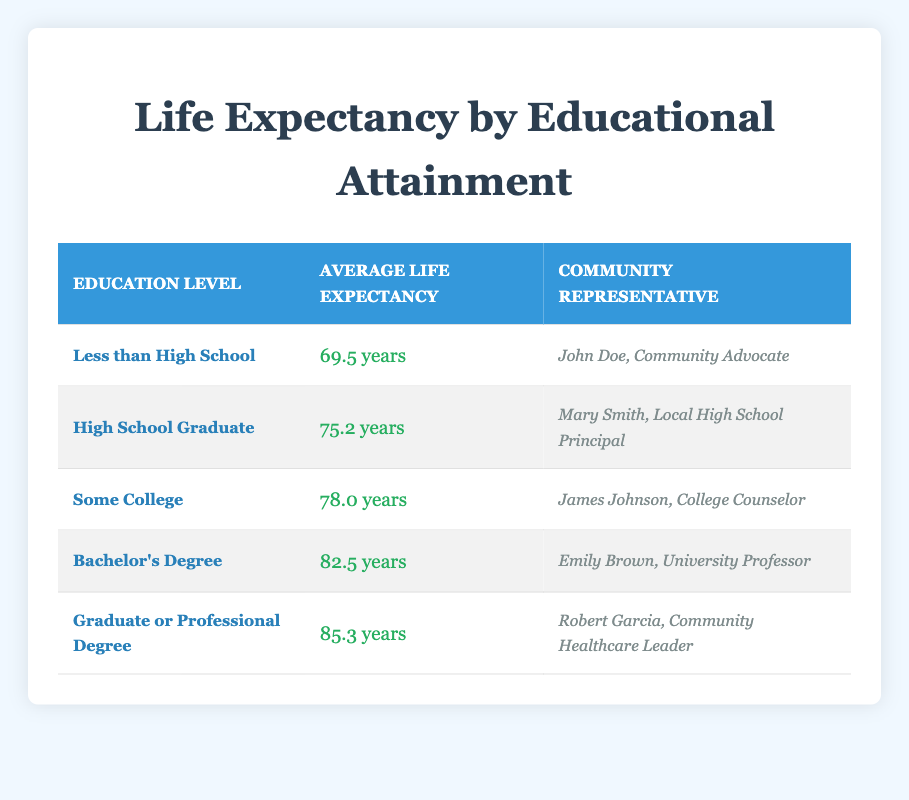What is the average life expectancy for individuals with a Bachelor's Degree? According to the table, the life expectancy for individuals with a Bachelor's Degree is listed as 82.5 years.
Answer: 82.5 years Who is the community representative for those with a Graduate or Professional Degree? The table indicates that Robert Garcia, a Community Healthcare Leader, is the representative for individuals with a Graduate or Professional Degree.
Answer: Robert Garcia, Community Healthcare Leader What is the difference in life expectancy between those with a High School Graduate and those with a Graduate or Professional Degree? The life expectancy for a High School Graduate is 75.2 years, and for a Graduate or Professional Degree, it is 85.3 years. The difference is 85.3 - 75.2 = 10.1 years.
Answer: 10.1 years Is the average life expectancy for individuals with less than a High School education higher than those who are High School Graduates? The table shows an average life expectancy of 69.5 years for those with less than a High School education and 75.2 years for High School Graduates. Thus, the statement is false.
Answer: No What is the average life expectancy for education levels below some college? The average life expectancy for Less than High School is 69.5 years and for High School Graduates is 75.2 years. To find the average of these, (69.5 + 75.2) / 2 = 72.35 years.
Answer: 72.35 years How many years more do individuals with a Graduate or Professional Degree live compared to those with some college education? The average life expectancy for those with a Graduate or Professional Degree is 85.3 years, and for those with Some College, it is 78.0 years. The difference is 85.3 - 78.0 = 7.3 years.
Answer: 7.3 years What is the highest average life expectancy shown in the table, and for which education level? The table indicates the highest average life expectancy is 85.3 years, which corresponds to individuals with a Graduate or Professional Degree.
Answer: 85.3 years, Graduate or Professional Degree Does the table indicate that average life expectancy increases with higher educational attainment? A review of the life expectancy data in the table shows a clear upward trend as education levels increase. Thus, the statement is true.
Answer: Yes 